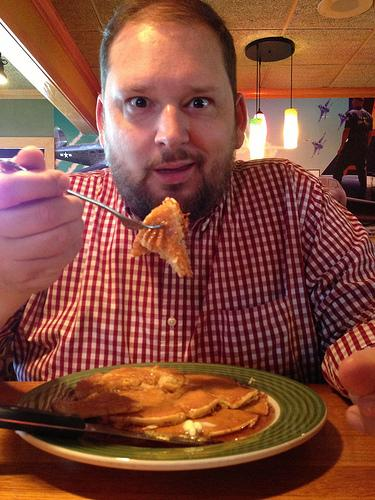Identify the colors, and the prominent object it is associated with, in the image. Red and white checkered shirt, green plate with pancakes, black handle on knife, and glowing light hanging from the ceiling. Describe the setting of the image, including the background elements and the central focus. The central focus is a man eating pancakes, with a mural featuring fighter planes in the background, lights and a speaker hanging from the ceiling and a wooden table. What are the different features of the man's shirt in the image? The man is wearing a red and white checkered shirt, has a breast pocket, and is described as having a "checked" pattern. Describe the objects in the image related to eating the pancakes. There is a green plate with a pile of cut pancakes drowned in syrup, a fork with a pancake piece on its end, and a knife on the plate. What are the details of the green plate and its contents in the image? The green plate with white trim contains a pile of cut pancakes drenched in maple syrup, and a knife on the plate. What is the person in the image wearing and what is he doing? The man is wearing a red and white checkered shirt, has a receding hairline and a mustache with a beard, and he is about to enjoy a bite of pancake. Which physical features of the man are distinctive and what is he doing? The man has a receding hairline, mustache, and beard, and he is eating a pancake on a fork spearing a peace of it. Identify the key elements of the image related to the man and his meal, and provide brief descriptions. Balding man with facial hair wearing a checkered shirt, green plate with pancakes covered in syrup, fork with a pancake piece, lights hanging from the ceiling, and a mural with planes in the background. What kind of decor, if any, is present in the background of the image? There is a mural featuring fighter planes on the far wall, lights hanging from the ceiling, and a white speaker on the ceiling. What are the facial features of the man in the image and what is he wearing? The man has a receding hairline, mustache, and beard, and he is wearing a plaid shirt with a breast pocket. 